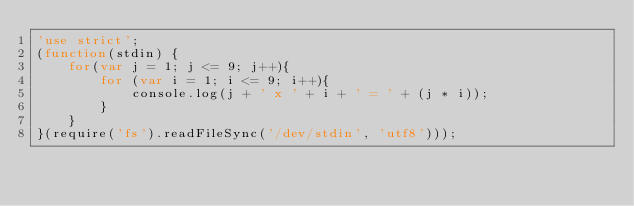Convert code to text. <code><loc_0><loc_0><loc_500><loc_500><_JavaScript_>'use strict';
(function(stdin) {
	for(var j = 1; j <= 9; j++){
		for (var i = 1; i <= 9; i++){
			console.log(j + ' x ' + i + ' = ' + (j * i));
		}
	}
}(require('fs').readFileSync('/dev/stdin', 'utf8')));</code> 